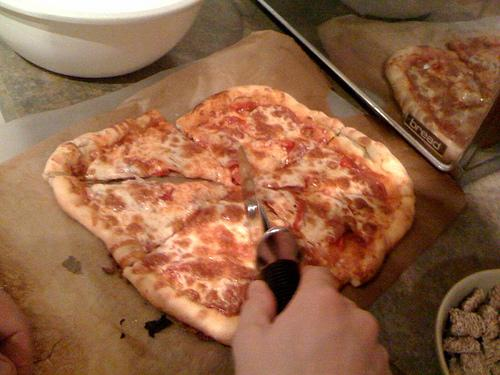Question: where is the pizza?
Choices:
A. On the plate.
B. On the counter.
C. In the box.
D. On the paper towel.
Answer with the letter. Answer: D Question: what is on the paper towel?
Choices:
A. A knife.
B. The pizza.
C. Crust.
D. Burnt edge.
Answer with the letter. Answer: B Question: how many pizzas are there?
Choices:
A. Two.
B. Three.
C. Zero.
D. One.
Answer with the letter. Answer: D Question: what is the paper towel on?
Choices:
A. The towel roll holder.
B. The counter.
C. The man's lap.
D. The plate.
Answer with the letter. Answer: B 